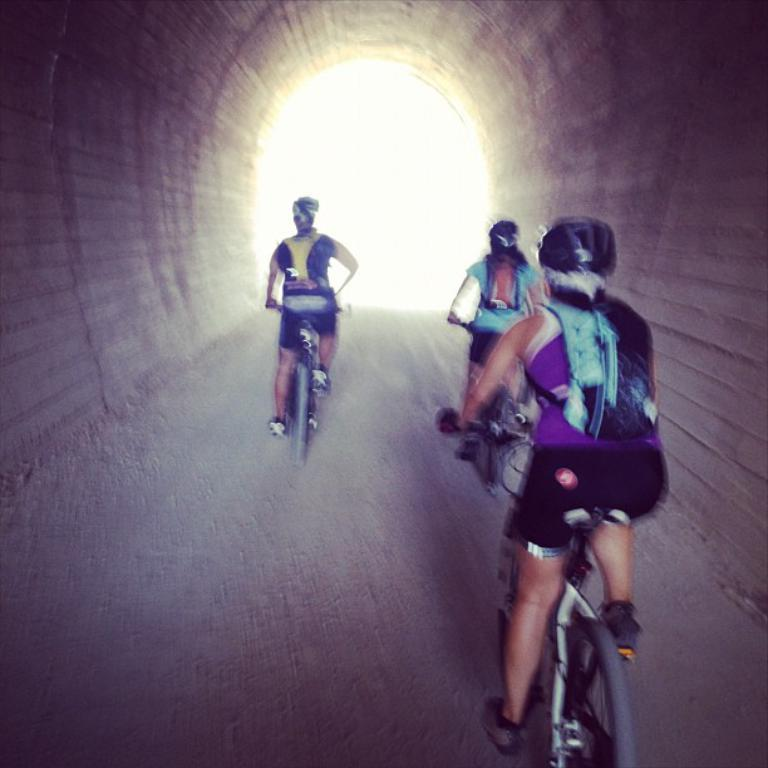What are the people in the image doing? The people in the image are riding bicycles. Where are the people riding their bicycles? The people are on a road. What feature can be seen in the distance in the image? There is a tunnel in the image. What type of chair is placed in the middle of the road in the image? There is no chair present in the image; the people are riding bicycles on the road. 